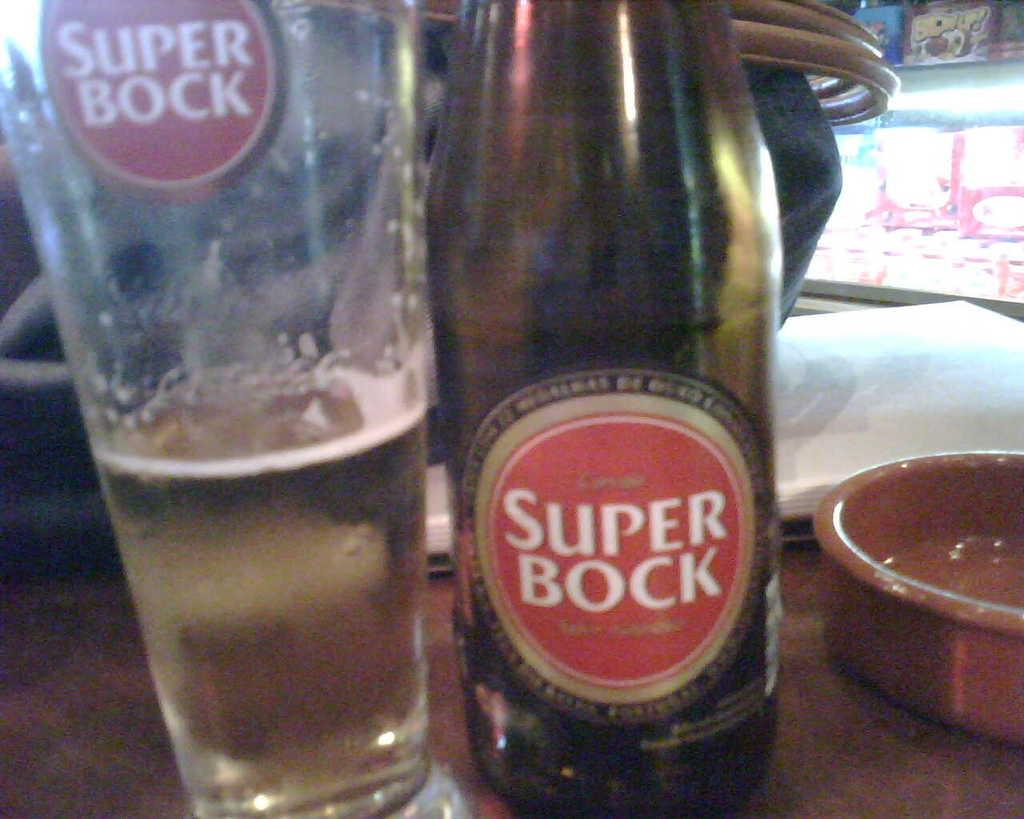What is featured on the bottle in the image? There is a bottle sticker in the image. What is in the glass that is visible in the image? There is a glass with a drink in the image. What type of container is present in the image besides the glass? There is a bowl in the image. What can be seen in the background of the image? There are lights and paper visible in the background of the image. What type of corn is being observed in the image? There is no corn present in the image. What is the tendency of the paper in the background of the image? The image does not show any movement or tendency of the paper; it is stationary. 